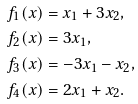Convert formula to latex. <formula><loc_0><loc_0><loc_500><loc_500>f _ { 1 } ( x ) & = x _ { 1 } + 3 x _ { 2 } , \\ f _ { 2 } ( x ) & = 3 x _ { 1 } , \\ f _ { 3 } ( x ) & = - 3 x _ { 1 } - x _ { 2 } , \\ f _ { 4 } ( x ) & = 2 x _ { 1 } + x _ { 2 } .</formula> 